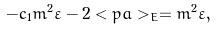<formula> <loc_0><loc_0><loc_500><loc_500>- c _ { 1 } m ^ { 2 } \varepsilon - 2 < p a > _ { E } = m ^ { 2 } \varepsilon ,</formula> 